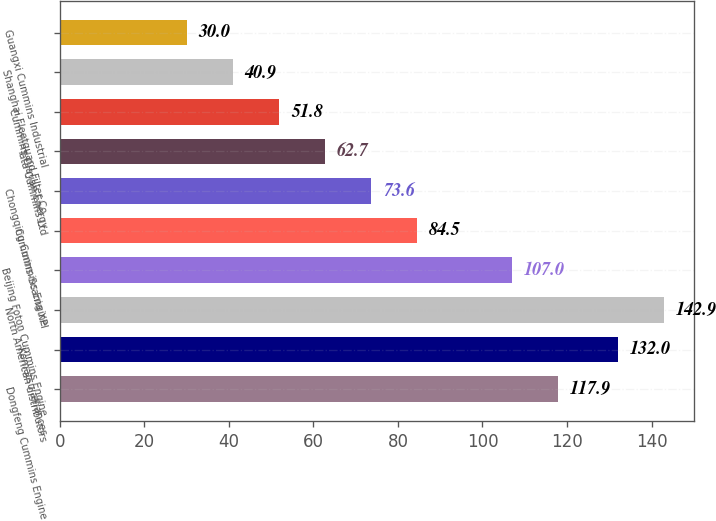<chart> <loc_0><loc_0><loc_500><loc_500><bar_chart><fcel>Dongfeng Cummins Engine<fcel>Komatsu alliances<fcel>North American distributors<fcel>Beijing Foton Cummins Engine<fcel>Cummins-Scania XPI<fcel>Chongqing Cummins Engine<fcel>Tata Cummins Ltd<fcel>Cummins Olayan Energy<fcel>Shanghai Fleetguard Filter Co<fcel>Guangxi Cummins Industrial<nl><fcel>117.9<fcel>132<fcel>142.9<fcel>107<fcel>84.5<fcel>73.6<fcel>62.7<fcel>51.8<fcel>40.9<fcel>30<nl></chart> 